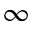Convert formula to latex. <formula><loc_0><loc_0><loc_500><loc_500>\infty</formula> 